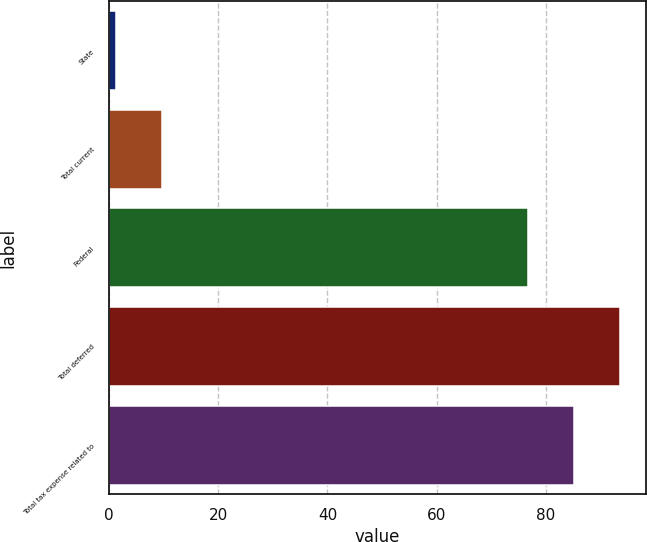Convert chart to OTSL. <chart><loc_0><loc_0><loc_500><loc_500><bar_chart><fcel>State<fcel>Total current<fcel>Federal<fcel>Total deferred<fcel>Total tax expense related to<nl><fcel>1.3<fcel>9.77<fcel>76.7<fcel>93.64<fcel>85.17<nl></chart> 